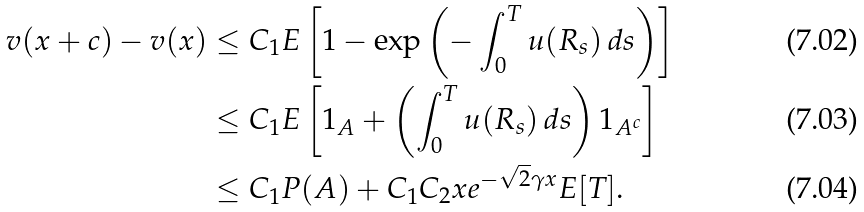Convert formula to latex. <formula><loc_0><loc_0><loc_500><loc_500>v ( x + c ) - v ( x ) & \leq C _ { 1 } E \left [ 1 - \exp \left ( - \int _ { 0 } ^ { T } u ( R _ { s } ) \, d s \right ) \right ] \\ & \leq C _ { 1 } E \left [ { 1 } _ { A } + \left ( \int _ { 0 } ^ { T } u ( R _ { s } ) \, d s \right ) { 1 } _ { A ^ { c } } \right ] \\ & \leq C _ { 1 } P ( A ) + C _ { 1 } C _ { 2 } x e ^ { - \sqrt { 2 } \gamma x } E [ T ] .</formula> 